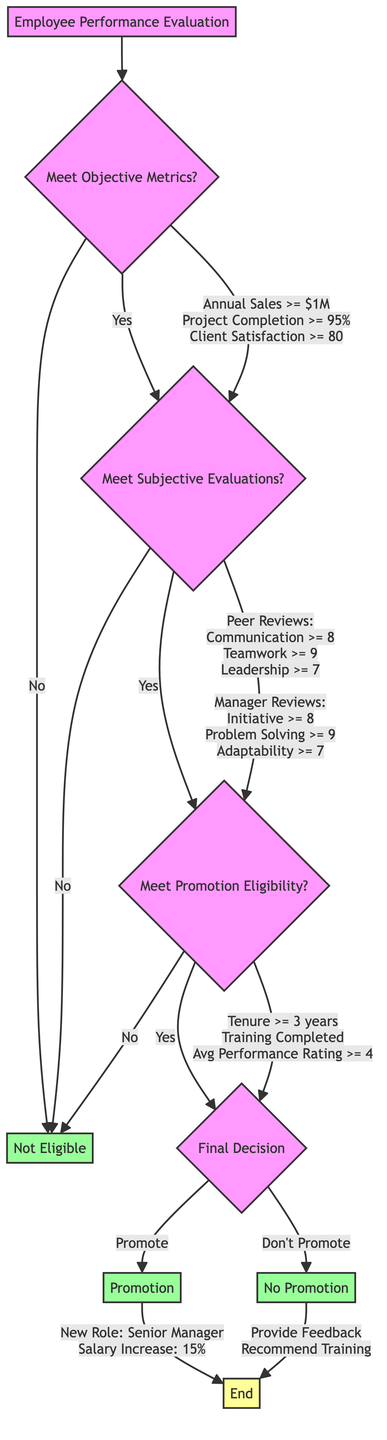What is the first decision in the diagram? The first decision in the diagram is whether the employee meets the objective metrics. It is represented by node B.
Answer: Meet Objective Metrics? What are the criteria for the objective metrics? The criteria for the objective metrics include Annual Sales >= $1M, Project Completion >= 95%, and Client Satisfaction >= 80. These are listed under node B in the diagram.
Answer: Annual Sales >= $1M, Project Completion >= 95%, Client Satisfaction >= 80 What happens if an employee does not meet the subjective evaluations? If an employee does not meet the subjective evaluations, they will not be eligible for promotion, which leads to node H indicating "Not Eligible."
Answer: Not Eligible What are the required scores in peer reviews to meet subjective evaluations? The required scores in peer reviews are Communication >= 8, Teamwork >= 9, and Leadership >= 7. These criteria are combined in node C of the diagram.
Answer: Communication >= 8, Teamwork >= 9, Leadership >= 7 How many years of minimum tenure are needed to meet promotion eligibility? The minimum tenure required to meet promotion eligibility is 3 years. This information is stated in the promotion eligibility criteria in node D.
Answer: 3 years What happens if an employee is promoted? If an employee is promoted, they will receive a new role of Senior Manager and a salary increase of 15%. This outcome is detailed in node F.
Answer: New Role: Senior Manager, Salary Increase: 15% What is provided to employees not promoted? Employees not promoted are provided with feedback and training recommendations, which includes Leadership Training and Advanced Project Management. This is represented in node G.
Answer: Provide Feedback, Recommend Training What is the average performance rating requirement over the last three years? The average performance rating requirement over the last three years is 4. This requirement is highlighted in the promotion eligibility criteria in node D.
Answer: 4 What is the overall flow if an employee meets all criteria? If an employee meets all criteria, the flow leads to promotion, resulting in a new role and salary increase. This leads to node I, which marks the end.
Answer: Promotion 